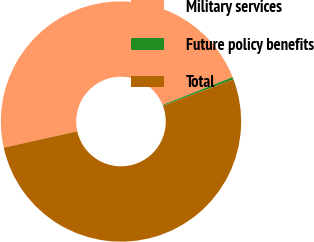<chart> <loc_0><loc_0><loc_500><loc_500><pie_chart><fcel>Military services<fcel>Future policy benefits<fcel>Total<nl><fcel>47.47%<fcel>0.31%<fcel>52.22%<nl></chart> 